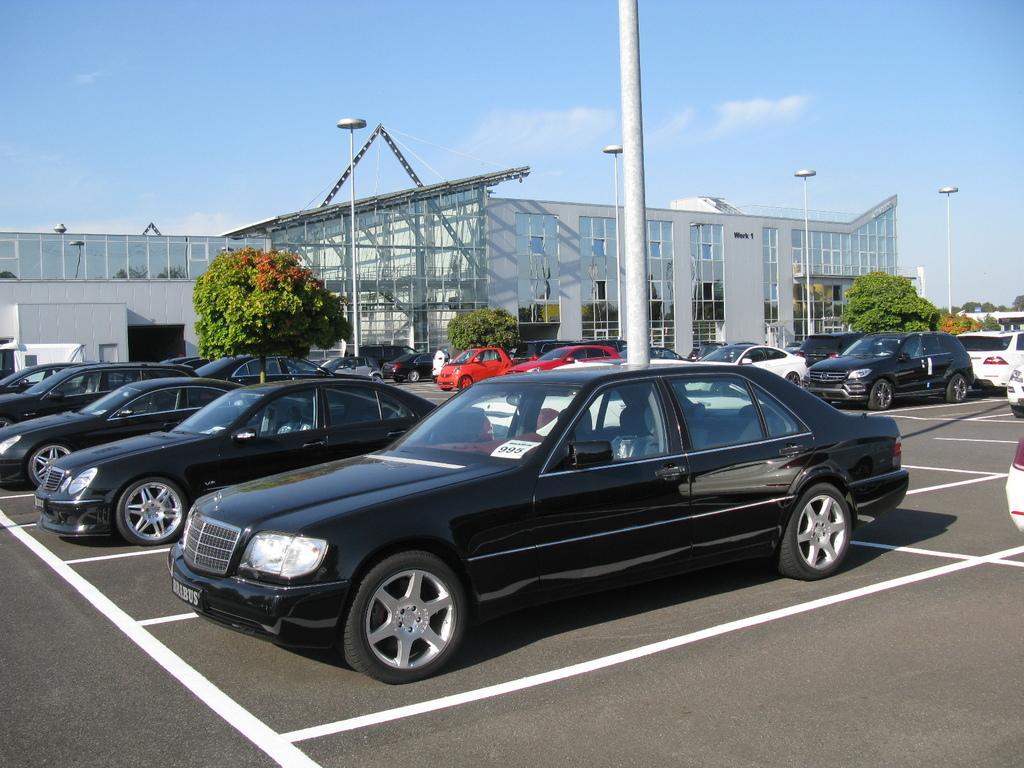Can you describe this image briefly? In this image we can see buildings with windows, metal poles, vehicles, trees and we can also see the sky. 